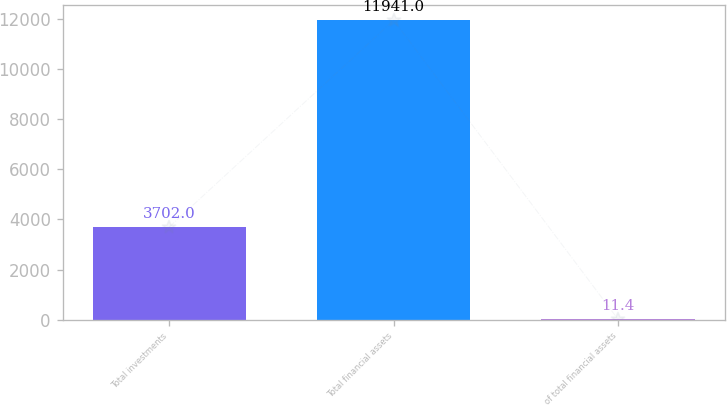Convert chart to OTSL. <chart><loc_0><loc_0><loc_500><loc_500><bar_chart><fcel>Total investments<fcel>Total financial assets<fcel>of total financial assets<nl><fcel>3702<fcel>11941<fcel>11.4<nl></chart> 